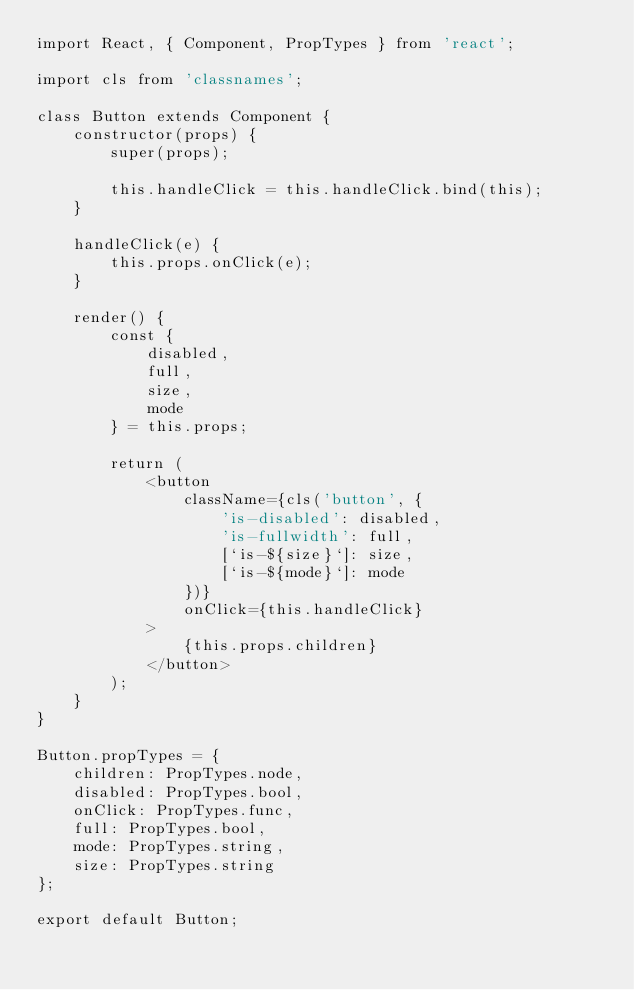Convert code to text. <code><loc_0><loc_0><loc_500><loc_500><_JavaScript_>import React, { Component, PropTypes } from 'react';

import cls from 'classnames';

class Button extends Component {
    constructor(props) {
        super(props);

        this.handleClick = this.handleClick.bind(this);
    }

    handleClick(e) {
        this.props.onClick(e);
    }

    render() {
        const {
            disabled,
            full,
            size,
            mode
        } = this.props;

        return (
            <button
                className={cls('button', {
                    'is-disabled': disabled,
                    'is-fullwidth': full,
                    [`is-${size}`]: size,
                    [`is-${mode}`]: mode
                })}
                onClick={this.handleClick}
            >
                {this.props.children}
            </button>
        );
    }
}

Button.propTypes = {
    children: PropTypes.node,
    disabled: PropTypes.bool,
    onClick: PropTypes.func,
    full: PropTypes.bool,
    mode: PropTypes.string,
    size: PropTypes.string
};

export default Button;
</code> 